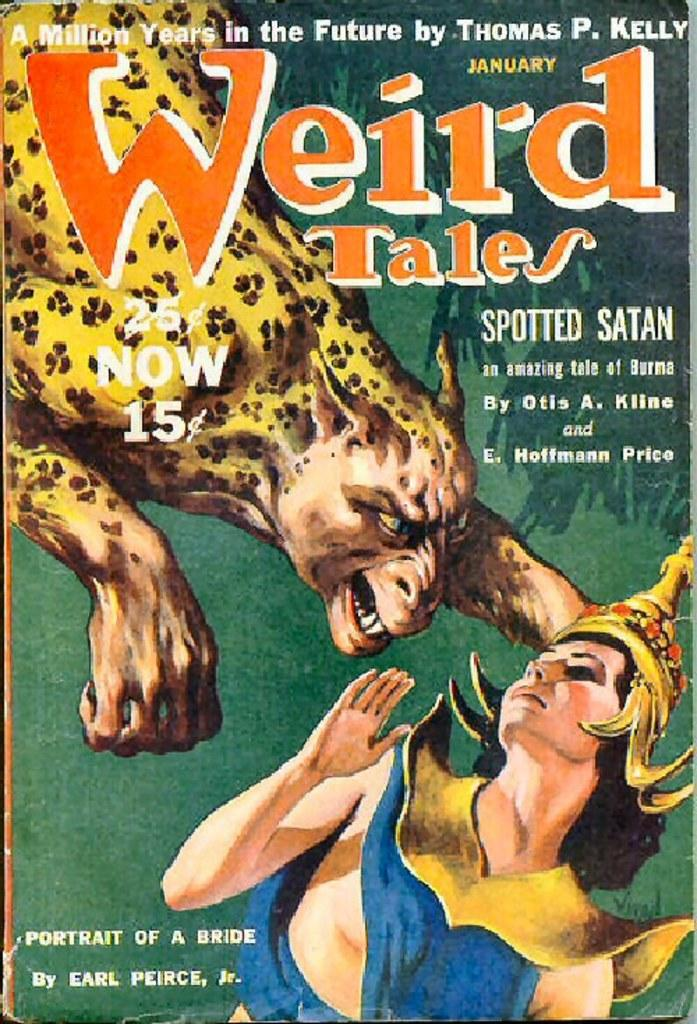<image>
Render a clear and concise summary of the photo. A book has January printed in yellow above the title. 